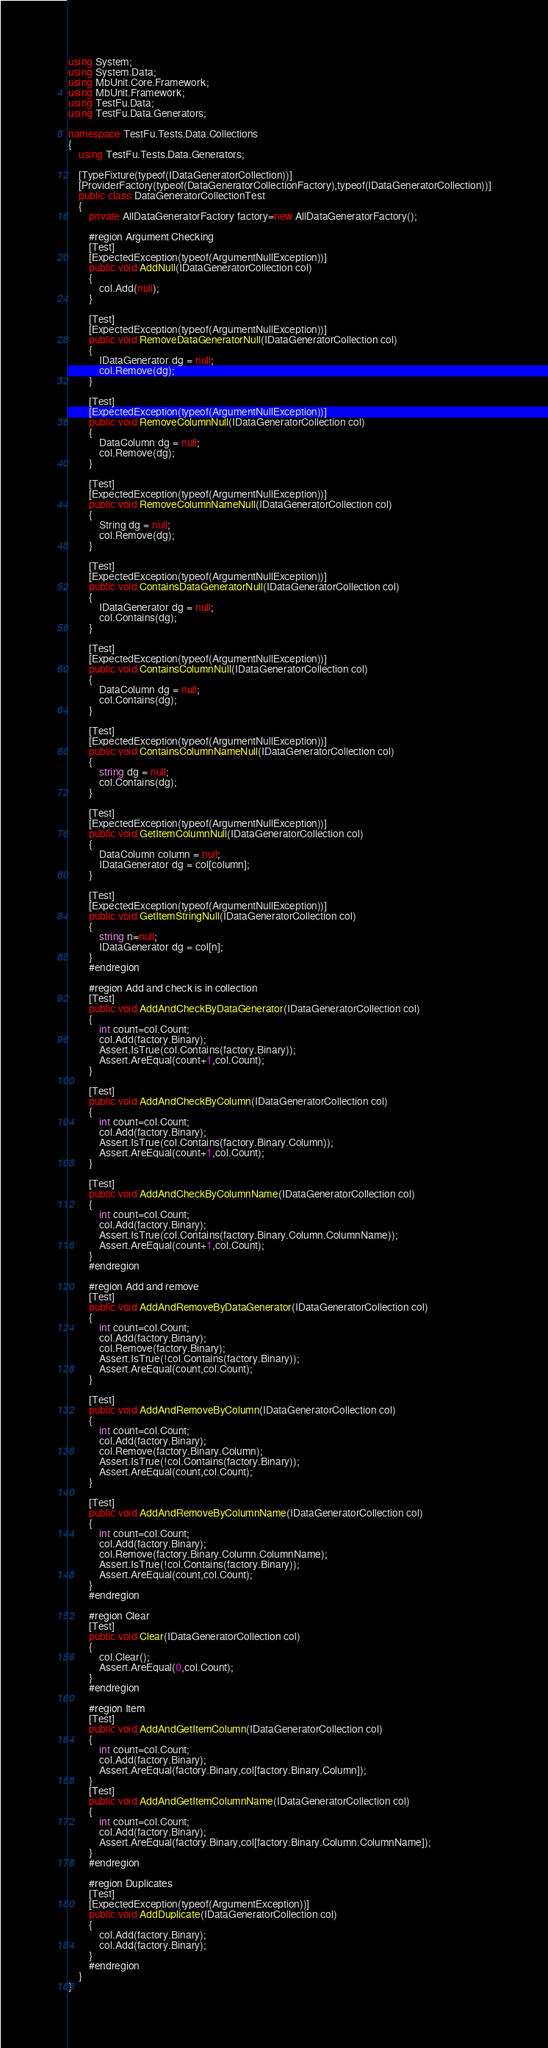<code> <loc_0><loc_0><loc_500><loc_500><_C#_>using System;
using System.Data;
using MbUnit.Core.Framework;
using MbUnit.Framework;
using TestFu.Data;
using TestFu.Data.Generators;

namespace TestFu.Tests.Data.Collections
{
	using TestFu.Tests.Data.Generators;

	[TypeFixture(typeof(IDataGeneratorCollection))]
	[ProviderFactory(typeof(DataGeneratorCollectionFactory),typeof(IDataGeneratorCollection))]
	public class DataGeneratorCollectionTest
	{
		private AllDataGeneratorFactory factory=new AllDataGeneratorFactory();

		#region Argument Checking
		[Test]
		[ExpectedException(typeof(ArgumentNullException))]
		public void AddNull(IDataGeneratorCollection col)
		{
			col.Add(null);
		}

		[Test]
		[ExpectedException(typeof(ArgumentNullException))]
		public void RemoveDataGeneratorNull(IDataGeneratorCollection col)
		{
			IDataGenerator dg = null;
			col.Remove(dg);
		}

		[Test]
		[ExpectedException(typeof(ArgumentNullException))]
		public void RemoveColumnNull(IDataGeneratorCollection col)
		{
			DataColumn dg = null;
			col.Remove(dg);
		}

		[Test]
		[ExpectedException(typeof(ArgumentNullException))]
		public void RemoveColumnNameNull(IDataGeneratorCollection col)
		{
			String dg = null;
			col.Remove(dg);
		}

		[Test]
		[ExpectedException(typeof(ArgumentNullException))]
		public void ContainsDataGeneratorNull(IDataGeneratorCollection col)
		{
			IDataGenerator dg = null;
			col.Contains(dg);
		}

		[Test]
		[ExpectedException(typeof(ArgumentNullException))]
		public void ContainsColumnNull(IDataGeneratorCollection col)
		{
			DataColumn dg = null;
			col.Contains(dg);
		}

		[Test]
		[ExpectedException(typeof(ArgumentNullException))]
		public void ContainsColumnNameNull(IDataGeneratorCollection col)
		{
			string dg = null;
			col.Contains(dg);
		}

		[Test]
		[ExpectedException(typeof(ArgumentNullException))]
		public void GetItemColumnNull(IDataGeneratorCollection col)
		{
			DataColumn column = null;
			IDataGenerator dg = col[column];
		}

		[Test]
		[ExpectedException(typeof(ArgumentNullException))]
		public void GetItemStringNull(IDataGeneratorCollection col)
		{
			string n=null;
			IDataGenerator dg = col[n];
		}
		#endregion

		#region Add and check is in collection
		[Test]
		public void AddAndCheckByDataGenerator(IDataGeneratorCollection col)
		{
			int count=col.Count;
			col.Add(factory.Binary);
			Assert.IsTrue(col.Contains(factory.Binary));
			Assert.AreEqual(count+1,col.Count);
		}

		[Test]
		public void AddAndCheckByColumn(IDataGeneratorCollection col)
		{
			int count=col.Count;
			col.Add(factory.Binary);
			Assert.IsTrue(col.Contains(factory.Binary.Column));
			Assert.AreEqual(count+1,col.Count);
		}

		[Test]
		public void AddAndCheckByColumnName(IDataGeneratorCollection col)
		{
			int count=col.Count;
			col.Add(factory.Binary);
			Assert.IsTrue(col.Contains(factory.Binary.Column.ColumnName));
			Assert.AreEqual(count+1,col.Count);
		}
		#endregion

		#region Add and remove
		[Test]
		public void AddAndRemoveByDataGenerator(IDataGeneratorCollection col)
		{
			int count=col.Count;
			col.Add(factory.Binary);
			col.Remove(factory.Binary);
			Assert.IsTrue(!col.Contains(factory.Binary));
			Assert.AreEqual(count,col.Count);
		}

		[Test]
		public void AddAndRemoveByColumn(IDataGeneratorCollection col)
		{
			int count=col.Count;
			col.Add(factory.Binary);
			col.Remove(factory.Binary.Column);
			Assert.IsTrue(!col.Contains(factory.Binary));
			Assert.AreEqual(count,col.Count);
		}

		[Test]
		public void AddAndRemoveByColumnName(IDataGeneratorCollection col)
		{
			int count=col.Count;
			col.Add(factory.Binary);
			col.Remove(factory.Binary.Column.ColumnName);
			Assert.IsTrue(!col.Contains(factory.Binary));
			Assert.AreEqual(count,col.Count);
		}
		#endregion

		#region Clear
		[Test]
		public void Clear(IDataGeneratorCollection col)
		{
			col.Clear();
			Assert.AreEqual(0,col.Count);
		}
		#endregion

		#region Item
		[Test]
		public void AddAndGetItemColumn(IDataGeneratorCollection col)
		{
			int count=col.Count;
			col.Add(factory.Binary);
			Assert.AreEqual(factory.Binary,col[factory.Binary.Column]);
		}
		[Test]
		public void AddAndGetItemColumnName(IDataGeneratorCollection col)
		{
			int count=col.Count;
			col.Add(factory.Binary);
			Assert.AreEqual(factory.Binary,col[factory.Binary.Column.ColumnName]);
		}
		#endregion

		#region Duplicates
		[Test]
		[ExpectedException(typeof(ArgumentException))]
		public void AddDuplicate(IDataGeneratorCollection col)
		{
			col.Add(factory.Binary);
			col.Add(factory.Binary);
		}
		#endregion
	}
}
</code> 